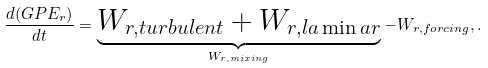Convert formula to latex. <formula><loc_0><loc_0><loc_500><loc_500>\frac { d ( G P E _ { r } ) } { d t } = \underbrace { W _ { r , t u r b u l e n t } + W _ { r , l a \min a r } } _ { W _ { r , m i x i n g } } - W _ { r , f o r c i n g } , .</formula> 